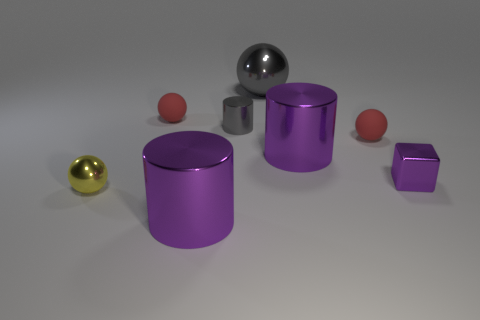What number of large objects have the same material as the small gray thing? 3 